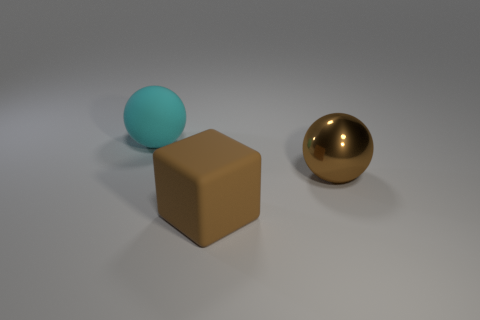There is a metallic thing to the right of the big matte thing in front of the big cyan matte ball; what size is it?
Your response must be concise. Large. Is the material of the big brown object that is left of the big brown sphere the same as the big object behind the brown ball?
Offer a very short reply. Yes. Does the big matte thing in front of the big cyan rubber object have the same color as the large rubber sphere?
Provide a short and direct response. No. There is a brown metal ball; what number of large cyan spheres are in front of it?
Your answer should be compact. 0. Does the big cube have the same material as the brown object that is behind the large cube?
Provide a short and direct response. No. Are there more large brown things that are in front of the big matte sphere than shiny things that are in front of the metal thing?
Your answer should be compact. Yes. Is there another large brown object that has the same shape as the big shiny thing?
Your answer should be very brief. No. Are any big blocks visible?
Provide a succinct answer. Yes. How many things are either balls left of the large metallic thing or large metallic spheres?
Your answer should be compact. 2. There is a large cube; does it have the same color as the ball that is to the right of the large cyan rubber sphere?
Your answer should be very brief. Yes. 